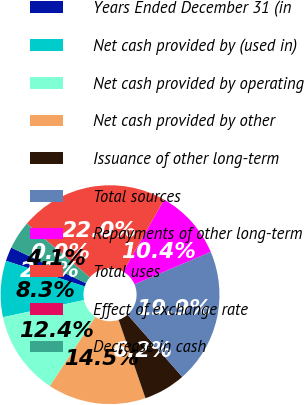Convert chart. <chart><loc_0><loc_0><loc_500><loc_500><pie_chart><fcel>Years Ended December 31 (in<fcel>Net cash provided by (used in)<fcel>Net cash provided by operating<fcel>Net cash provided by other<fcel>Issuance of other long-term<fcel>Total sources<fcel>Repayments of other long-term<fcel>Total uses<fcel>Effect of exchange rate<fcel>Decrease in cash<nl><fcel>2.08%<fcel>8.3%<fcel>12.44%<fcel>14.51%<fcel>6.23%<fcel>19.92%<fcel>10.37%<fcel>21.99%<fcel>0.01%<fcel>4.15%<nl></chart> 